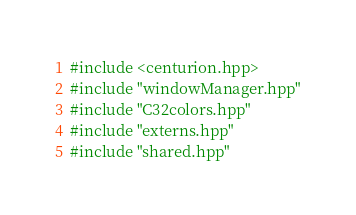<code> <loc_0><loc_0><loc_500><loc_500><_C++_>#include <centurion.hpp>
#include "windowManager.hpp"
#include "C32colors.hpp"
#include "externs.hpp"
#include "shared.hpp"</code> 